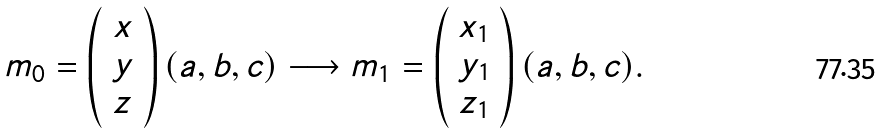<formula> <loc_0><loc_0><loc_500><loc_500>m _ { 0 } = \left ( \begin{array} { c } x \\ y \\ z \end{array} \right ) ( a , b , c ) \longrightarrow m _ { 1 } = \left ( \begin{array} { c } x _ { 1 } \\ y _ { 1 } \\ z _ { 1 } \end{array} \right ) ( a , b , c ) .</formula> 